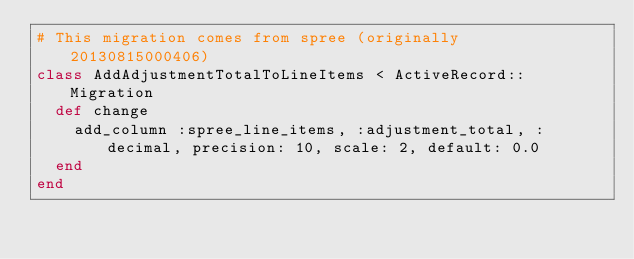Convert code to text. <code><loc_0><loc_0><loc_500><loc_500><_Ruby_># This migration comes from spree (originally 20130815000406)
class AddAdjustmentTotalToLineItems < ActiveRecord::Migration
  def change
    add_column :spree_line_items, :adjustment_total, :decimal, precision: 10, scale: 2, default: 0.0
  end
end
</code> 